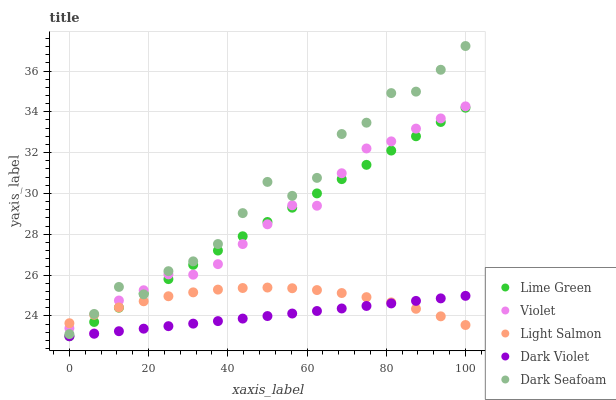Does Dark Violet have the minimum area under the curve?
Answer yes or no. Yes. Does Dark Seafoam have the maximum area under the curve?
Answer yes or no. Yes. Does Lime Green have the minimum area under the curve?
Answer yes or no. No. Does Lime Green have the maximum area under the curve?
Answer yes or no. No. Is Dark Violet the smoothest?
Answer yes or no. Yes. Is Dark Seafoam the roughest?
Answer yes or no. Yes. Is Lime Green the smoothest?
Answer yes or no. No. Is Lime Green the roughest?
Answer yes or no. No. Does Lime Green have the lowest value?
Answer yes or no. Yes. Does Dark Seafoam have the lowest value?
Answer yes or no. No. Does Dark Seafoam have the highest value?
Answer yes or no. Yes. Does Lime Green have the highest value?
Answer yes or no. No. Is Dark Violet less than Violet?
Answer yes or no. Yes. Is Violet greater than Dark Violet?
Answer yes or no. Yes. Does Violet intersect Light Salmon?
Answer yes or no. Yes. Is Violet less than Light Salmon?
Answer yes or no. No. Is Violet greater than Light Salmon?
Answer yes or no. No. Does Dark Violet intersect Violet?
Answer yes or no. No. 